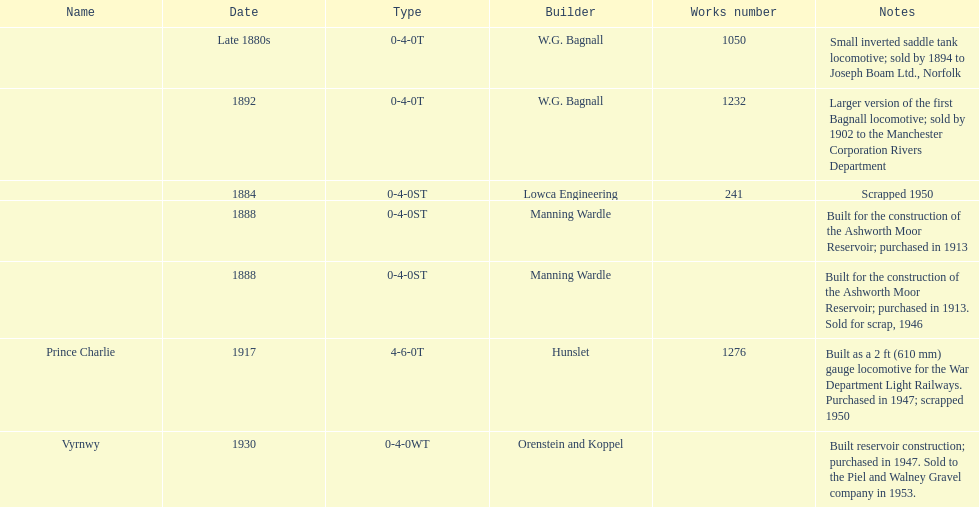Which locomotive builder built a locomotive after 1888 and built the locomotive as a 2ft gauge locomotive? Hunslet. 